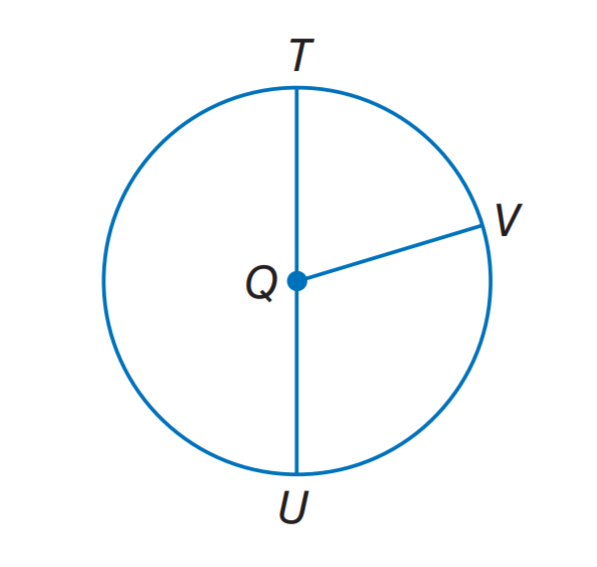Question: If Q T = 11, what is Q U.
Choices:
A. 7
B. 8
C. 11
D. 16
Answer with the letter. Answer: C Question: If T U = 14, what it the radius of \odot Q.
Choices:
A. 7
B. 8
C. 11
D. 16
Answer with the letter. Answer: A Question: If Q V = 8, what it the diameter of \odot Q.
Choices:
A. 7
B. 8
C. 11
D. 16
Answer with the letter. Answer: D 